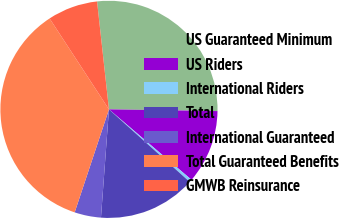<chart> <loc_0><loc_0><loc_500><loc_500><pie_chart><fcel>US Guaranteed Minimum<fcel>US Riders<fcel>International Riders<fcel>Total<fcel>International Guaranteed<fcel>Total Guaranteed Benefits<fcel>GMWB Reinsurance<nl><fcel>27.0%<fcel>10.99%<fcel>0.41%<fcel>14.52%<fcel>3.94%<fcel>35.68%<fcel>7.46%<nl></chart> 